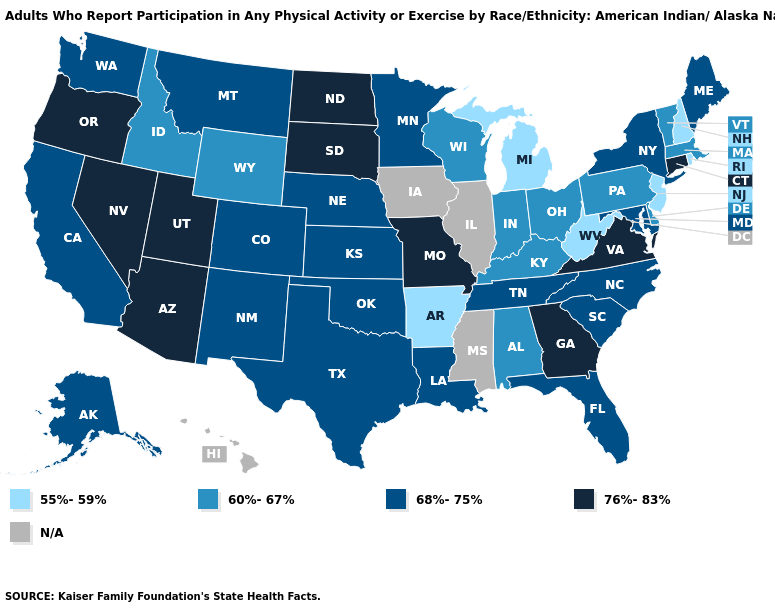Does the first symbol in the legend represent the smallest category?
Give a very brief answer. Yes. Among the states that border Nebraska , does Wyoming have the highest value?
Be succinct. No. Does Nebraska have the highest value in the MidWest?
Keep it brief. No. Among the states that border Arkansas , which have the lowest value?
Quick response, please. Louisiana, Oklahoma, Tennessee, Texas. Does the map have missing data?
Answer briefly. Yes. Name the states that have a value in the range N/A?
Quick response, please. Hawaii, Illinois, Iowa, Mississippi. Name the states that have a value in the range 68%-75%?
Short answer required. Alaska, California, Colorado, Florida, Kansas, Louisiana, Maine, Maryland, Minnesota, Montana, Nebraska, New Mexico, New York, North Carolina, Oklahoma, South Carolina, Tennessee, Texas, Washington. What is the value of Maryland?
Short answer required. 68%-75%. What is the highest value in states that border Pennsylvania?
Write a very short answer. 68%-75%. Which states have the lowest value in the South?
Answer briefly. Arkansas, West Virginia. What is the value of Nebraska?
Quick response, please. 68%-75%. Name the states that have a value in the range 68%-75%?
Keep it brief. Alaska, California, Colorado, Florida, Kansas, Louisiana, Maine, Maryland, Minnesota, Montana, Nebraska, New Mexico, New York, North Carolina, Oklahoma, South Carolina, Tennessee, Texas, Washington. Name the states that have a value in the range 76%-83%?
Write a very short answer. Arizona, Connecticut, Georgia, Missouri, Nevada, North Dakota, Oregon, South Dakota, Utah, Virginia. What is the lowest value in the South?
Give a very brief answer. 55%-59%. Which states hav the highest value in the South?
Concise answer only. Georgia, Virginia. 